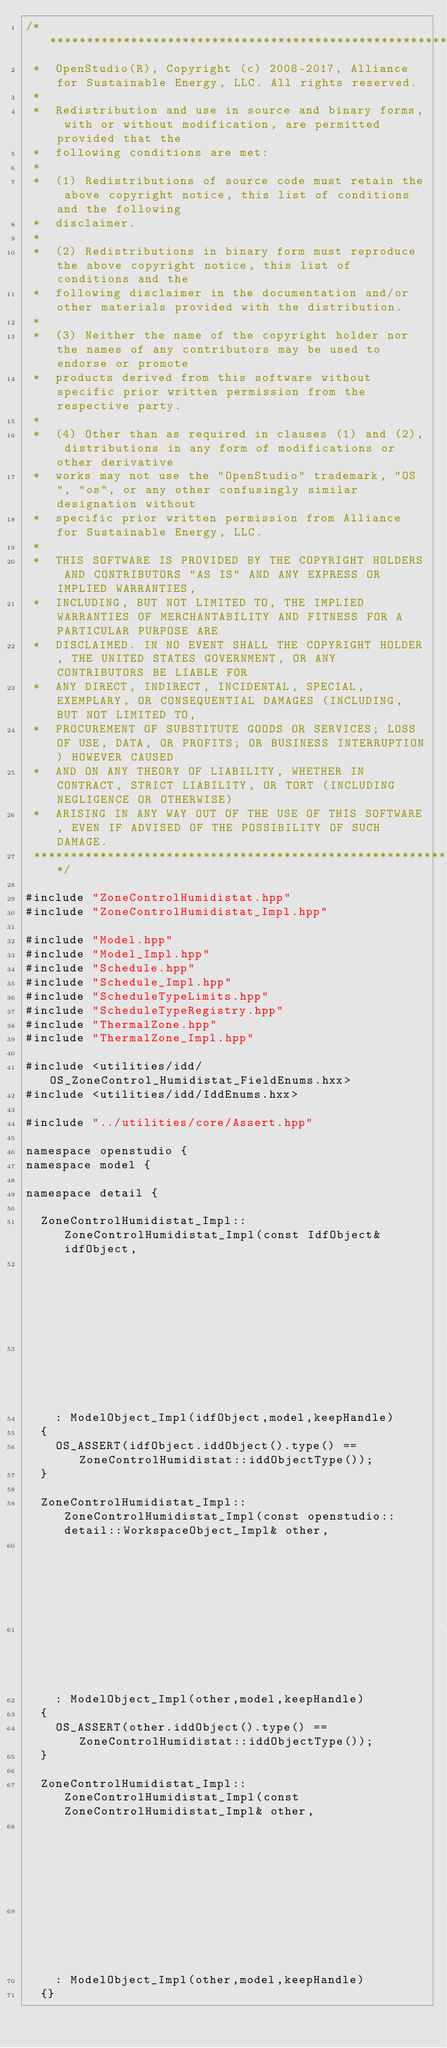Convert code to text. <code><loc_0><loc_0><loc_500><loc_500><_C++_>/***********************************************************************************************************************
 *  OpenStudio(R), Copyright (c) 2008-2017, Alliance for Sustainable Energy, LLC. All rights reserved.
 *
 *  Redistribution and use in source and binary forms, with or without modification, are permitted provided that the
 *  following conditions are met:
 *
 *  (1) Redistributions of source code must retain the above copyright notice, this list of conditions and the following
 *  disclaimer.
 *
 *  (2) Redistributions in binary form must reproduce the above copyright notice, this list of conditions and the
 *  following disclaimer in the documentation and/or other materials provided with the distribution.
 *
 *  (3) Neither the name of the copyright holder nor the names of any contributors may be used to endorse or promote
 *  products derived from this software without specific prior written permission from the respective party.
 *
 *  (4) Other than as required in clauses (1) and (2), distributions in any form of modifications or other derivative
 *  works may not use the "OpenStudio" trademark, "OS", "os", or any other confusingly similar designation without
 *  specific prior written permission from Alliance for Sustainable Energy, LLC.
 *
 *  THIS SOFTWARE IS PROVIDED BY THE COPYRIGHT HOLDERS AND CONTRIBUTORS "AS IS" AND ANY EXPRESS OR IMPLIED WARRANTIES,
 *  INCLUDING, BUT NOT LIMITED TO, THE IMPLIED WARRANTIES OF MERCHANTABILITY AND FITNESS FOR A PARTICULAR PURPOSE ARE
 *  DISCLAIMED. IN NO EVENT SHALL THE COPYRIGHT HOLDER, THE UNITED STATES GOVERNMENT, OR ANY CONTRIBUTORS BE LIABLE FOR
 *  ANY DIRECT, INDIRECT, INCIDENTAL, SPECIAL, EXEMPLARY, OR CONSEQUENTIAL DAMAGES (INCLUDING, BUT NOT LIMITED TO,
 *  PROCUREMENT OF SUBSTITUTE GOODS OR SERVICES; LOSS OF USE, DATA, OR PROFITS; OR BUSINESS INTERRUPTION) HOWEVER CAUSED
 *  AND ON ANY THEORY OF LIABILITY, WHETHER IN CONTRACT, STRICT LIABILITY, OR TORT (INCLUDING NEGLIGENCE OR OTHERWISE)
 *  ARISING IN ANY WAY OUT OF THE USE OF THIS SOFTWARE, EVEN IF ADVISED OF THE POSSIBILITY OF SUCH DAMAGE.
 **********************************************************************************************************************/

#include "ZoneControlHumidistat.hpp"
#include "ZoneControlHumidistat_Impl.hpp"

#include "Model.hpp"
#include "Model_Impl.hpp"
#include "Schedule.hpp"
#include "Schedule_Impl.hpp"
#include "ScheduleTypeLimits.hpp"
#include "ScheduleTypeRegistry.hpp"
#include "ThermalZone.hpp"
#include "ThermalZone_Impl.hpp"

#include <utilities/idd/OS_ZoneControl_Humidistat_FieldEnums.hxx>
#include <utilities/idd/IddEnums.hxx>

#include "../utilities/core/Assert.hpp"

namespace openstudio {
namespace model {

namespace detail {

  ZoneControlHumidistat_Impl::ZoneControlHumidistat_Impl(const IdfObject& idfObject,
                                                         Model_Impl* model,
                                                         bool keepHandle)
    : ModelObject_Impl(idfObject,model,keepHandle)
  {
    OS_ASSERT(idfObject.iddObject().type() == ZoneControlHumidistat::iddObjectType());
  }

  ZoneControlHumidistat_Impl::ZoneControlHumidistat_Impl(const openstudio::detail::WorkspaceObject_Impl& other,
                                                         Model_Impl* model,
                                                         bool keepHandle)
    : ModelObject_Impl(other,model,keepHandle)
  {
    OS_ASSERT(other.iddObject().type() == ZoneControlHumidistat::iddObjectType());
  }

  ZoneControlHumidistat_Impl::ZoneControlHumidistat_Impl(const ZoneControlHumidistat_Impl& other,
                                                         Model_Impl* model,
                                                         bool keepHandle)
    : ModelObject_Impl(other,model,keepHandle)
  {}
</code> 